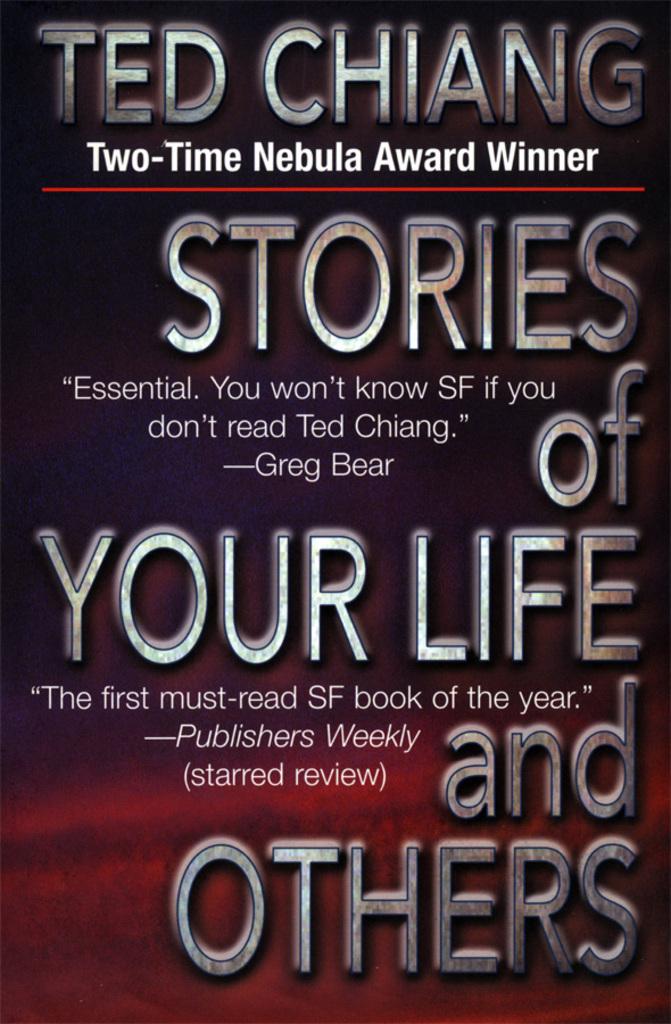Who is the two-time nebula award winner?
Provide a succinct answer. Ted chiang. What did greg bear say about the book?
Keep it short and to the point. Essential. you won't know sf if you don't read ted chiang. 